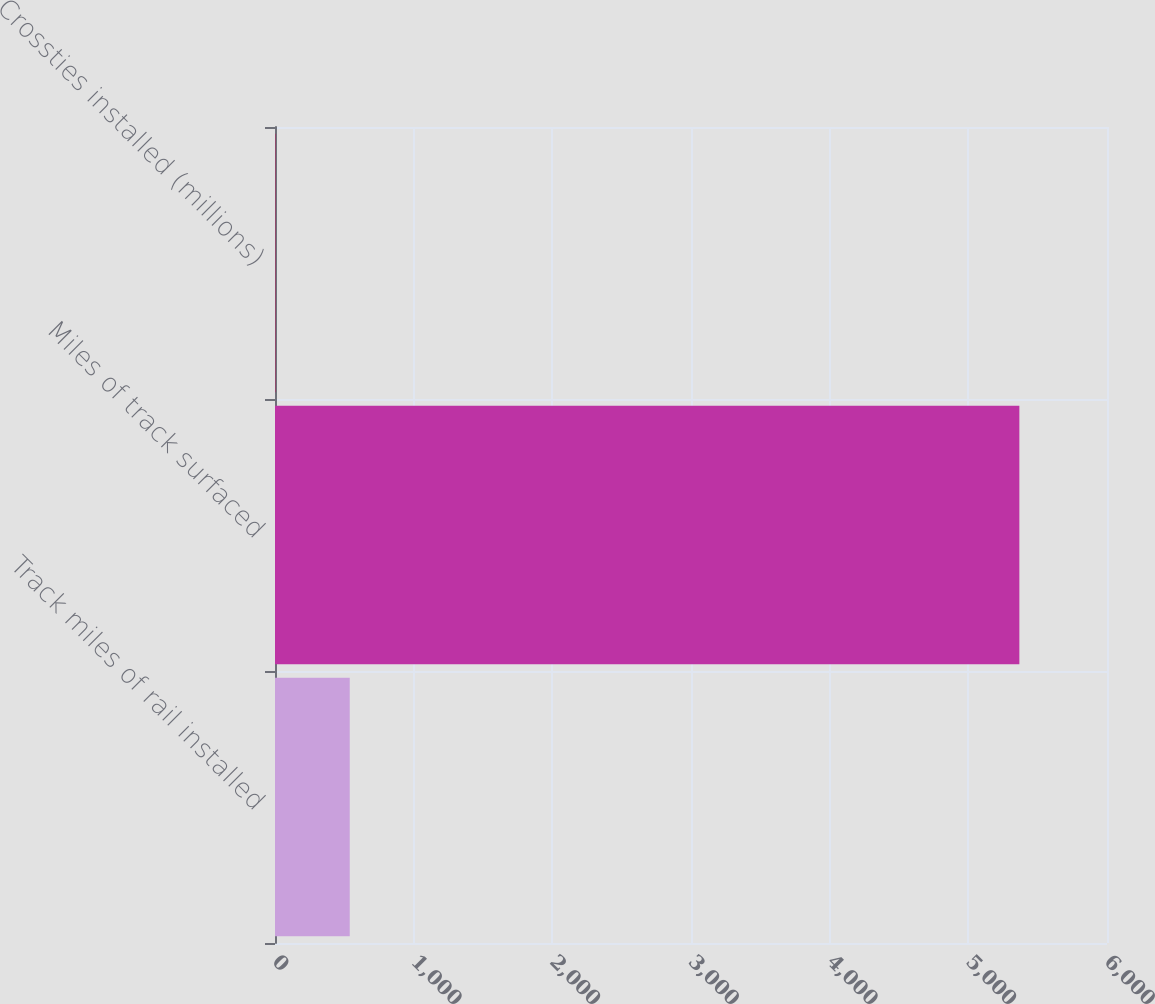Convert chart. <chart><loc_0><loc_0><loc_500><loc_500><bar_chart><fcel>Track miles of rail installed<fcel>Miles of track surfaced<fcel>Crossties installed (millions)<nl><fcel>539.05<fcel>5368<fcel>2.5<nl></chart> 